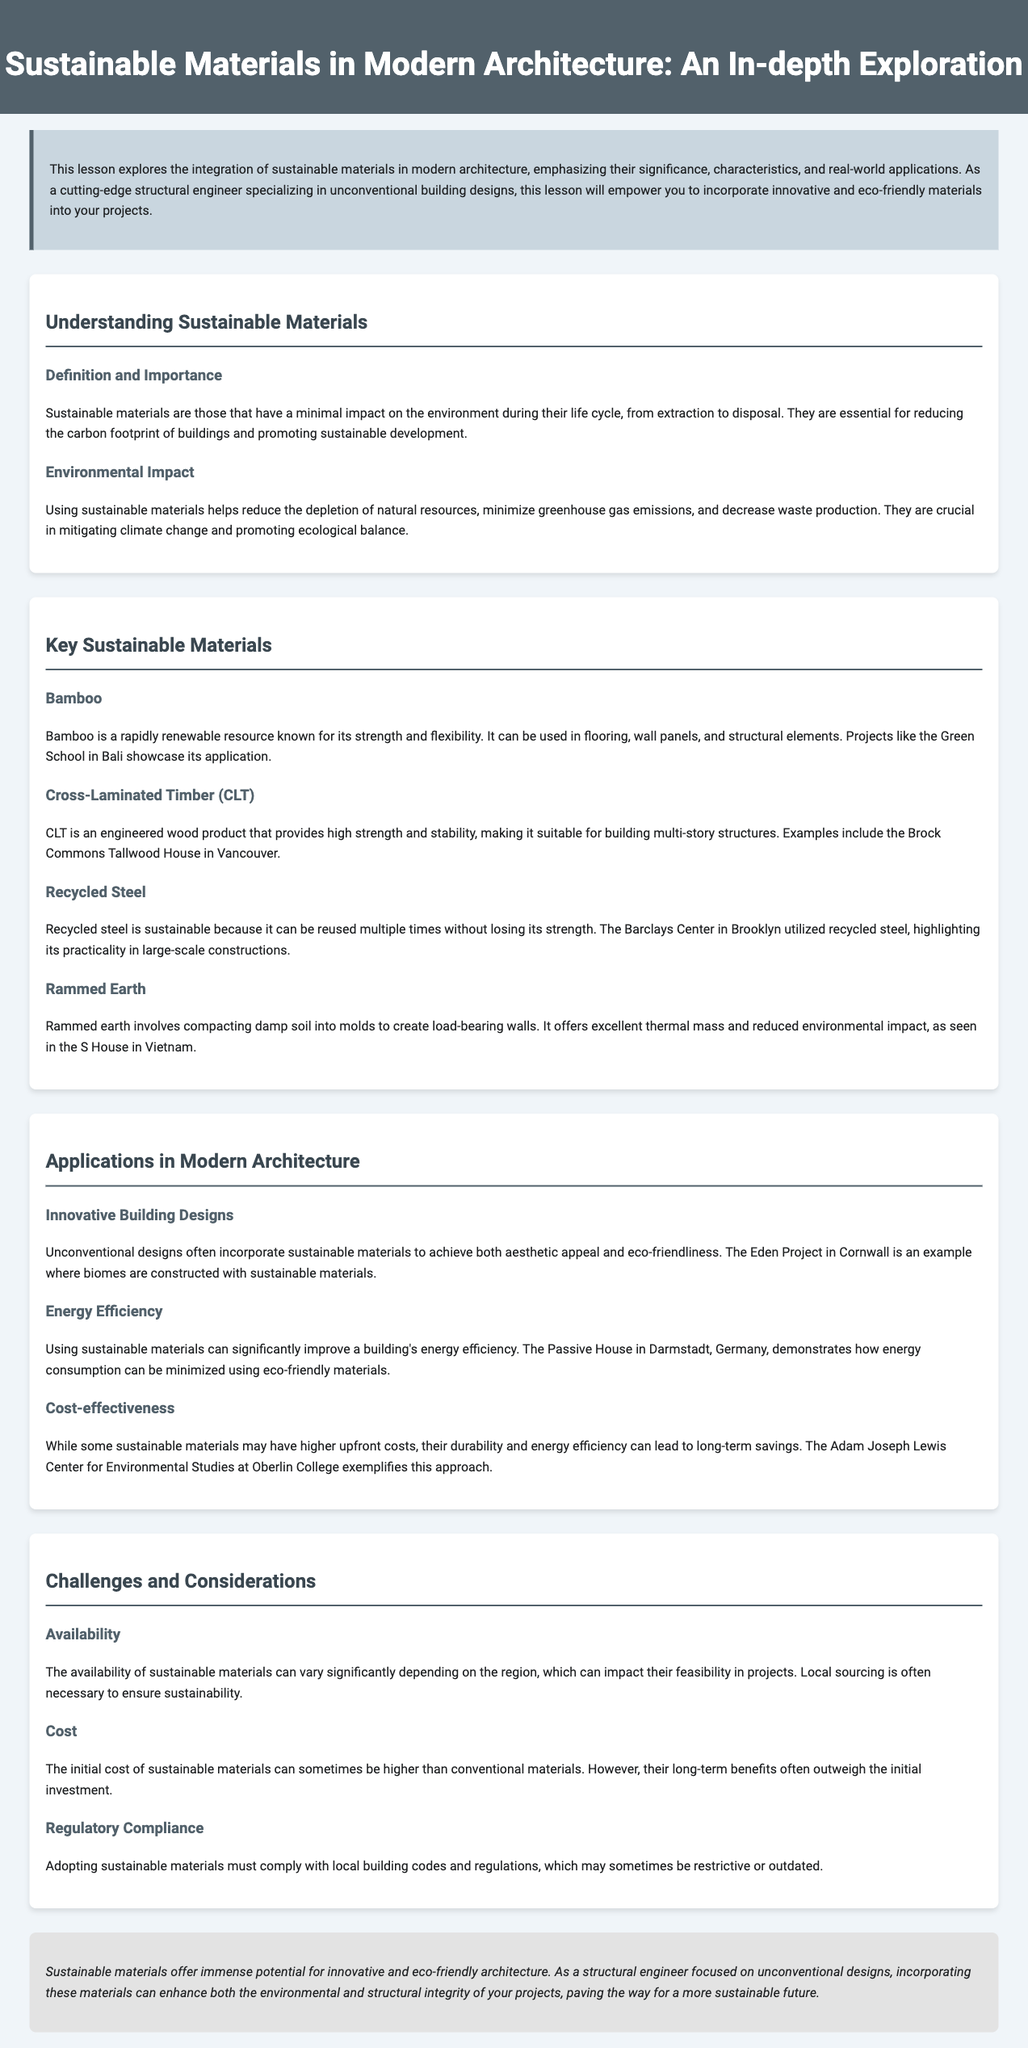What are sustainable materials? Sustainable materials are those that have a minimal impact on the environment during their life cycle, from extraction to disposal.
Answer: Sustainable materials What is an example of a building that uses Recycled Steel? The Barclays Center in Brooklyn utilized recycled steel, highlighting its practicality in large-scale constructions.
Answer: Barclays Center Which material is known for its strength and flexibility? Bamboo is a rapidly renewable resource known for its strength and flexibility.
Answer: Bamboo What is a benefit of using sustainable materials in buildings? Using sustainable materials helps reduce the depletion of natural resources, minimize greenhouse gas emissions, and decrease waste production.
Answer: Reduces depletion of natural resources What architectural example demonstrates energy efficiency through sustainable materials? The Passive House in Darmstadt, Germany, demonstrates how energy consumption can be minimized using eco-friendly materials.
Answer: Passive House What challenge is associated with the availability of sustainable materials? The availability of sustainable materials can vary significantly depending on the region, which can impact their feasibility in projects.
Answer: Varies regionally Which wood product provides high strength and stability for multi-story structures? CLT is an engineered wood product that provides high strength and stability.
Answer: CLT What is the conclusion of the lesson about sustainable materials? Sustainable materials offer immense potential for innovative and eco-friendly architecture.
Answer: Immense potential for innovative architecture 